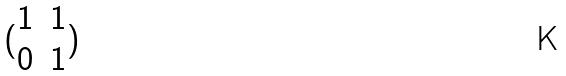<formula> <loc_0><loc_0><loc_500><loc_500>( \begin{matrix} 1 & 1 \\ 0 & 1 \\ \end{matrix} )</formula> 